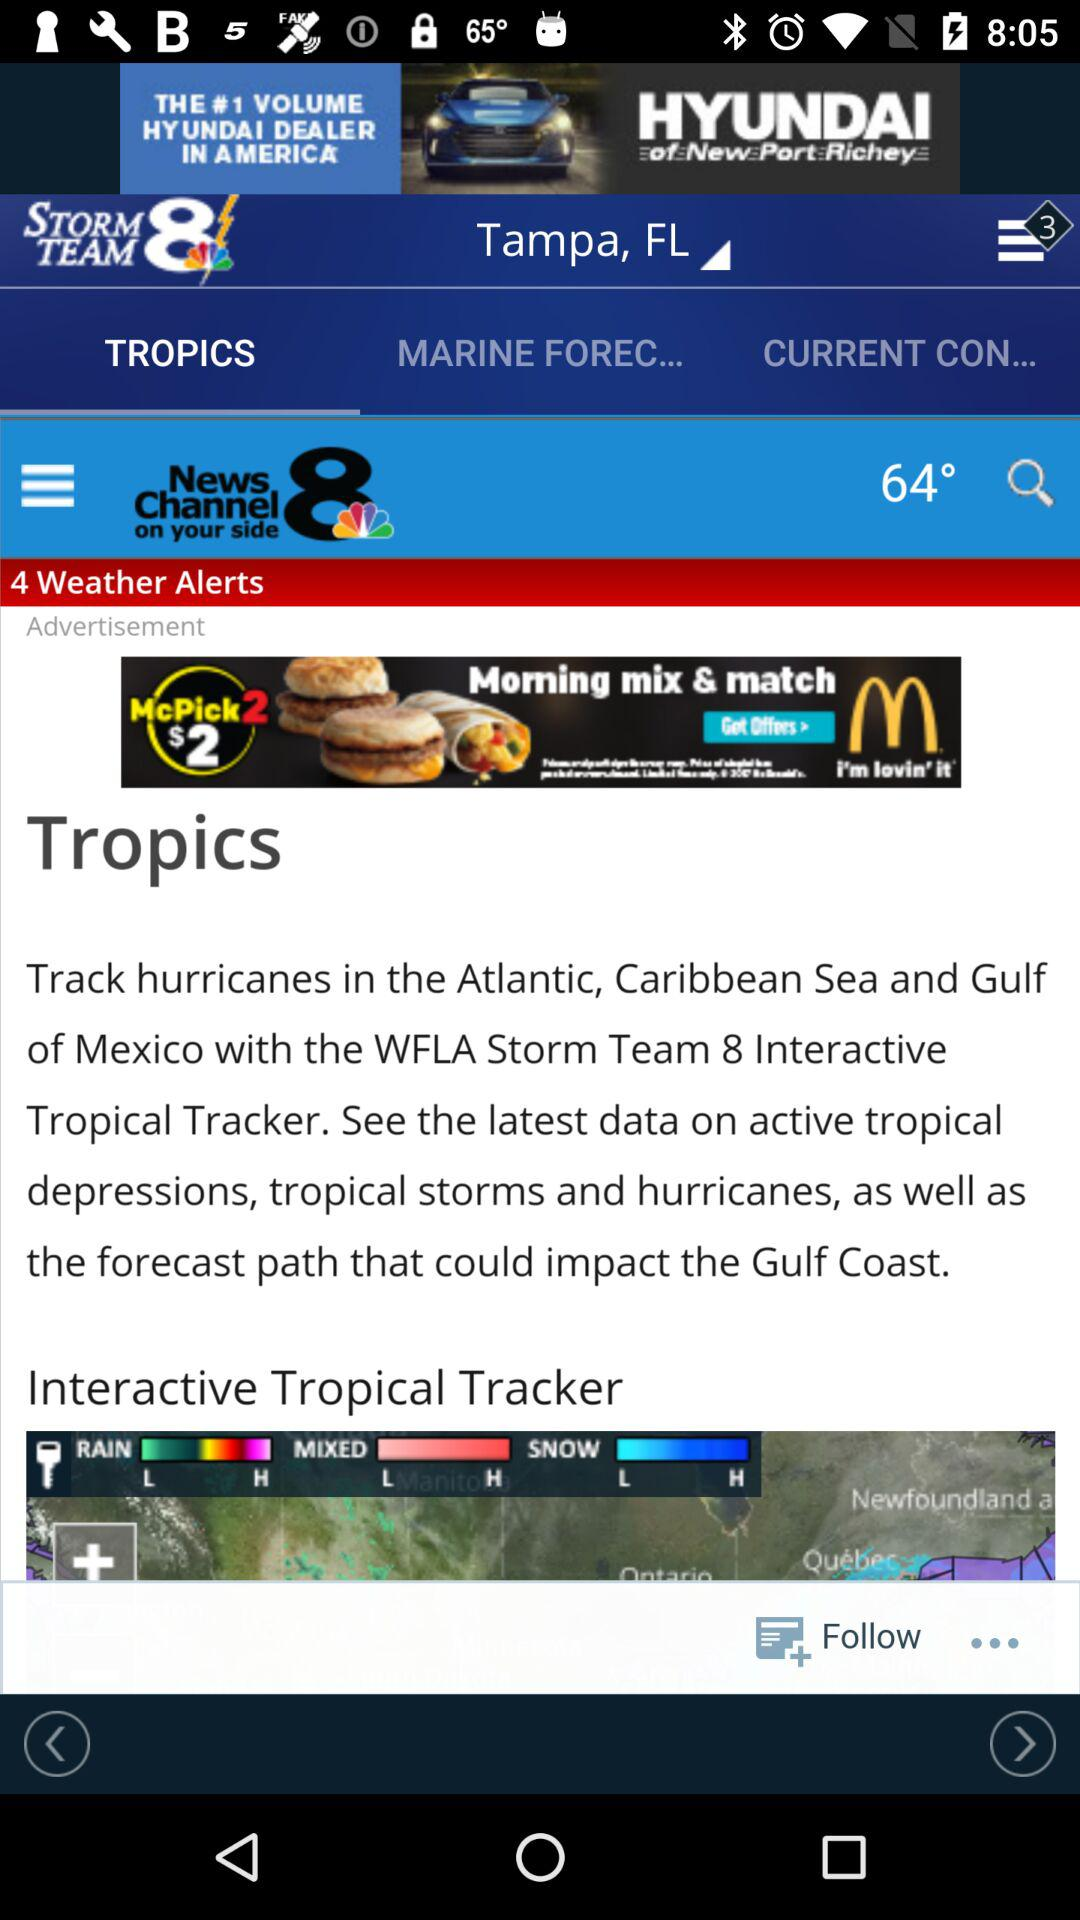What is the current temperature? The current temperature is 64°. 